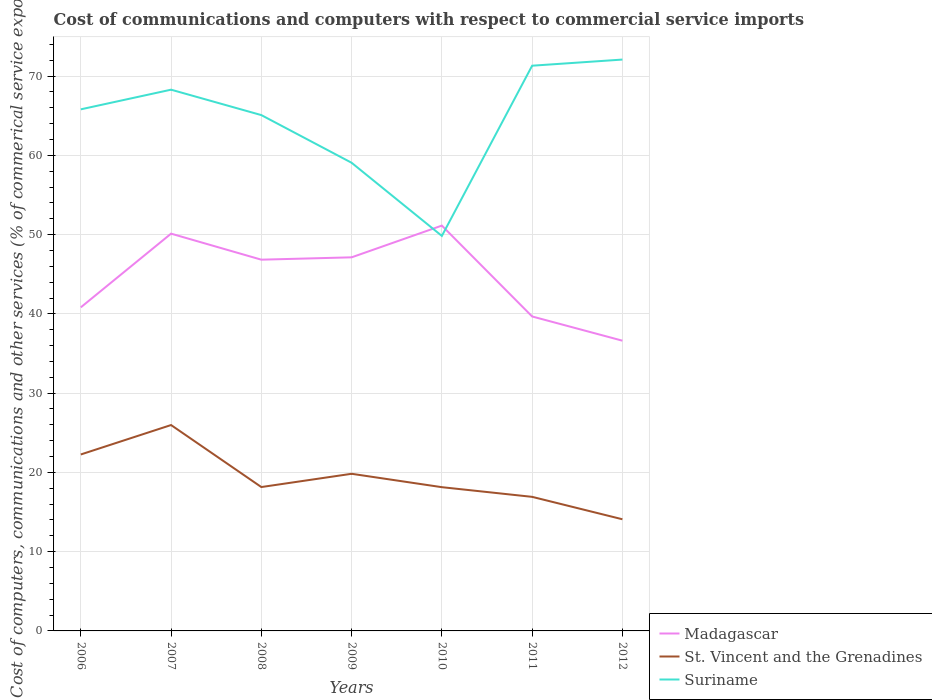Does the line corresponding to St. Vincent and the Grenadines intersect with the line corresponding to Suriname?
Provide a succinct answer. No. Across all years, what is the maximum cost of communications and computers in Suriname?
Your answer should be compact. 49.83. What is the total cost of communications and computers in Suriname in the graph?
Provide a short and direct response. -3.8. What is the difference between the highest and the second highest cost of communications and computers in St. Vincent and the Grenadines?
Your response must be concise. 11.89. How many lines are there?
Your answer should be compact. 3. Are the values on the major ticks of Y-axis written in scientific E-notation?
Make the answer very short. No. Does the graph contain any zero values?
Offer a terse response. No. Does the graph contain grids?
Offer a terse response. Yes. How many legend labels are there?
Ensure brevity in your answer.  3. What is the title of the graph?
Your answer should be compact. Cost of communications and computers with respect to commercial service imports. What is the label or title of the X-axis?
Provide a short and direct response. Years. What is the label or title of the Y-axis?
Give a very brief answer. Cost of computers, communications and other services (% of commerical service exports). What is the Cost of computers, communications and other services (% of commerical service exports) in Madagascar in 2006?
Offer a terse response. 40.82. What is the Cost of computers, communications and other services (% of commerical service exports) in St. Vincent and the Grenadines in 2006?
Make the answer very short. 22.26. What is the Cost of computers, communications and other services (% of commerical service exports) of Suriname in 2006?
Your response must be concise. 65.8. What is the Cost of computers, communications and other services (% of commerical service exports) in Madagascar in 2007?
Your answer should be very brief. 50.12. What is the Cost of computers, communications and other services (% of commerical service exports) of St. Vincent and the Grenadines in 2007?
Provide a short and direct response. 25.97. What is the Cost of computers, communications and other services (% of commerical service exports) in Suriname in 2007?
Offer a terse response. 68.28. What is the Cost of computers, communications and other services (% of commerical service exports) in Madagascar in 2008?
Make the answer very short. 46.84. What is the Cost of computers, communications and other services (% of commerical service exports) in St. Vincent and the Grenadines in 2008?
Make the answer very short. 18.15. What is the Cost of computers, communications and other services (% of commerical service exports) of Suriname in 2008?
Offer a very short reply. 65.08. What is the Cost of computers, communications and other services (% of commerical service exports) of Madagascar in 2009?
Keep it short and to the point. 47.13. What is the Cost of computers, communications and other services (% of commerical service exports) of St. Vincent and the Grenadines in 2009?
Offer a very short reply. 19.82. What is the Cost of computers, communications and other services (% of commerical service exports) in Suriname in 2009?
Your answer should be compact. 59.06. What is the Cost of computers, communications and other services (% of commerical service exports) of Madagascar in 2010?
Provide a succinct answer. 51.13. What is the Cost of computers, communications and other services (% of commerical service exports) of St. Vincent and the Grenadines in 2010?
Give a very brief answer. 18.13. What is the Cost of computers, communications and other services (% of commerical service exports) of Suriname in 2010?
Your answer should be very brief. 49.83. What is the Cost of computers, communications and other services (% of commerical service exports) of Madagascar in 2011?
Your response must be concise. 39.67. What is the Cost of computers, communications and other services (% of commerical service exports) in St. Vincent and the Grenadines in 2011?
Offer a terse response. 16.91. What is the Cost of computers, communications and other services (% of commerical service exports) in Suriname in 2011?
Offer a very short reply. 71.31. What is the Cost of computers, communications and other services (% of commerical service exports) of Madagascar in 2012?
Your answer should be compact. 36.62. What is the Cost of computers, communications and other services (% of commerical service exports) in St. Vincent and the Grenadines in 2012?
Your answer should be compact. 14.09. What is the Cost of computers, communications and other services (% of commerical service exports) in Suriname in 2012?
Ensure brevity in your answer.  72.08. Across all years, what is the maximum Cost of computers, communications and other services (% of commerical service exports) of Madagascar?
Your answer should be compact. 51.13. Across all years, what is the maximum Cost of computers, communications and other services (% of commerical service exports) in St. Vincent and the Grenadines?
Keep it short and to the point. 25.97. Across all years, what is the maximum Cost of computers, communications and other services (% of commerical service exports) in Suriname?
Keep it short and to the point. 72.08. Across all years, what is the minimum Cost of computers, communications and other services (% of commerical service exports) of Madagascar?
Keep it short and to the point. 36.62. Across all years, what is the minimum Cost of computers, communications and other services (% of commerical service exports) in St. Vincent and the Grenadines?
Keep it short and to the point. 14.09. Across all years, what is the minimum Cost of computers, communications and other services (% of commerical service exports) in Suriname?
Keep it short and to the point. 49.83. What is the total Cost of computers, communications and other services (% of commerical service exports) of Madagascar in the graph?
Your answer should be very brief. 312.33. What is the total Cost of computers, communications and other services (% of commerical service exports) of St. Vincent and the Grenadines in the graph?
Provide a succinct answer. 135.34. What is the total Cost of computers, communications and other services (% of commerical service exports) in Suriname in the graph?
Make the answer very short. 451.45. What is the difference between the Cost of computers, communications and other services (% of commerical service exports) of Madagascar in 2006 and that in 2007?
Make the answer very short. -9.3. What is the difference between the Cost of computers, communications and other services (% of commerical service exports) of St. Vincent and the Grenadines in 2006 and that in 2007?
Your answer should be compact. -3.71. What is the difference between the Cost of computers, communications and other services (% of commerical service exports) in Suriname in 2006 and that in 2007?
Provide a succinct answer. -2.48. What is the difference between the Cost of computers, communications and other services (% of commerical service exports) in Madagascar in 2006 and that in 2008?
Keep it short and to the point. -6.02. What is the difference between the Cost of computers, communications and other services (% of commerical service exports) in St. Vincent and the Grenadines in 2006 and that in 2008?
Provide a succinct answer. 4.11. What is the difference between the Cost of computers, communications and other services (% of commerical service exports) of Suriname in 2006 and that in 2008?
Your response must be concise. 0.73. What is the difference between the Cost of computers, communications and other services (% of commerical service exports) in Madagascar in 2006 and that in 2009?
Offer a terse response. -6.31. What is the difference between the Cost of computers, communications and other services (% of commerical service exports) in St. Vincent and the Grenadines in 2006 and that in 2009?
Provide a succinct answer. 2.44. What is the difference between the Cost of computers, communications and other services (% of commerical service exports) of Suriname in 2006 and that in 2009?
Give a very brief answer. 6.74. What is the difference between the Cost of computers, communications and other services (% of commerical service exports) of Madagascar in 2006 and that in 2010?
Your answer should be very brief. -10.31. What is the difference between the Cost of computers, communications and other services (% of commerical service exports) in St. Vincent and the Grenadines in 2006 and that in 2010?
Offer a terse response. 4.13. What is the difference between the Cost of computers, communications and other services (% of commerical service exports) of Suriname in 2006 and that in 2010?
Ensure brevity in your answer.  15.97. What is the difference between the Cost of computers, communications and other services (% of commerical service exports) in Madagascar in 2006 and that in 2011?
Offer a very short reply. 1.15. What is the difference between the Cost of computers, communications and other services (% of commerical service exports) in St. Vincent and the Grenadines in 2006 and that in 2011?
Make the answer very short. 5.35. What is the difference between the Cost of computers, communications and other services (% of commerical service exports) of Suriname in 2006 and that in 2011?
Your answer should be very brief. -5.5. What is the difference between the Cost of computers, communications and other services (% of commerical service exports) in Madagascar in 2006 and that in 2012?
Keep it short and to the point. 4.21. What is the difference between the Cost of computers, communications and other services (% of commerical service exports) of St. Vincent and the Grenadines in 2006 and that in 2012?
Provide a succinct answer. 8.17. What is the difference between the Cost of computers, communications and other services (% of commerical service exports) of Suriname in 2006 and that in 2012?
Keep it short and to the point. -6.28. What is the difference between the Cost of computers, communications and other services (% of commerical service exports) in Madagascar in 2007 and that in 2008?
Your answer should be compact. 3.28. What is the difference between the Cost of computers, communications and other services (% of commerical service exports) of St. Vincent and the Grenadines in 2007 and that in 2008?
Offer a very short reply. 7.82. What is the difference between the Cost of computers, communications and other services (% of commerical service exports) of Suriname in 2007 and that in 2008?
Give a very brief answer. 3.21. What is the difference between the Cost of computers, communications and other services (% of commerical service exports) of Madagascar in 2007 and that in 2009?
Your response must be concise. 2.99. What is the difference between the Cost of computers, communications and other services (% of commerical service exports) of St. Vincent and the Grenadines in 2007 and that in 2009?
Give a very brief answer. 6.15. What is the difference between the Cost of computers, communications and other services (% of commerical service exports) of Suriname in 2007 and that in 2009?
Ensure brevity in your answer.  9.22. What is the difference between the Cost of computers, communications and other services (% of commerical service exports) in Madagascar in 2007 and that in 2010?
Provide a short and direct response. -1.02. What is the difference between the Cost of computers, communications and other services (% of commerical service exports) in St. Vincent and the Grenadines in 2007 and that in 2010?
Provide a short and direct response. 7.84. What is the difference between the Cost of computers, communications and other services (% of commerical service exports) of Suriname in 2007 and that in 2010?
Your answer should be compact. 18.45. What is the difference between the Cost of computers, communications and other services (% of commerical service exports) in Madagascar in 2007 and that in 2011?
Your answer should be very brief. 10.45. What is the difference between the Cost of computers, communications and other services (% of commerical service exports) in St. Vincent and the Grenadines in 2007 and that in 2011?
Make the answer very short. 9.06. What is the difference between the Cost of computers, communications and other services (% of commerical service exports) in Suriname in 2007 and that in 2011?
Your answer should be compact. -3.02. What is the difference between the Cost of computers, communications and other services (% of commerical service exports) in Madagascar in 2007 and that in 2012?
Keep it short and to the point. 13.5. What is the difference between the Cost of computers, communications and other services (% of commerical service exports) in St. Vincent and the Grenadines in 2007 and that in 2012?
Your answer should be very brief. 11.89. What is the difference between the Cost of computers, communications and other services (% of commerical service exports) of Suriname in 2007 and that in 2012?
Give a very brief answer. -3.8. What is the difference between the Cost of computers, communications and other services (% of commerical service exports) of Madagascar in 2008 and that in 2009?
Your answer should be compact. -0.3. What is the difference between the Cost of computers, communications and other services (% of commerical service exports) of St. Vincent and the Grenadines in 2008 and that in 2009?
Ensure brevity in your answer.  -1.67. What is the difference between the Cost of computers, communications and other services (% of commerical service exports) in Suriname in 2008 and that in 2009?
Provide a succinct answer. 6.01. What is the difference between the Cost of computers, communications and other services (% of commerical service exports) in Madagascar in 2008 and that in 2010?
Keep it short and to the point. -4.3. What is the difference between the Cost of computers, communications and other services (% of commerical service exports) of St. Vincent and the Grenadines in 2008 and that in 2010?
Your answer should be compact. 0.02. What is the difference between the Cost of computers, communications and other services (% of commerical service exports) in Suriname in 2008 and that in 2010?
Give a very brief answer. 15.24. What is the difference between the Cost of computers, communications and other services (% of commerical service exports) of Madagascar in 2008 and that in 2011?
Your answer should be very brief. 7.16. What is the difference between the Cost of computers, communications and other services (% of commerical service exports) of St. Vincent and the Grenadines in 2008 and that in 2011?
Ensure brevity in your answer.  1.24. What is the difference between the Cost of computers, communications and other services (% of commerical service exports) of Suriname in 2008 and that in 2011?
Ensure brevity in your answer.  -6.23. What is the difference between the Cost of computers, communications and other services (% of commerical service exports) of Madagascar in 2008 and that in 2012?
Provide a succinct answer. 10.22. What is the difference between the Cost of computers, communications and other services (% of commerical service exports) of St. Vincent and the Grenadines in 2008 and that in 2012?
Your response must be concise. 4.07. What is the difference between the Cost of computers, communications and other services (% of commerical service exports) of Suriname in 2008 and that in 2012?
Provide a succinct answer. -7.01. What is the difference between the Cost of computers, communications and other services (% of commerical service exports) in Madagascar in 2009 and that in 2010?
Provide a succinct answer. -4. What is the difference between the Cost of computers, communications and other services (% of commerical service exports) in St. Vincent and the Grenadines in 2009 and that in 2010?
Your response must be concise. 1.69. What is the difference between the Cost of computers, communications and other services (% of commerical service exports) in Suriname in 2009 and that in 2010?
Your answer should be compact. 9.23. What is the difference between the Cost of computers, communications and other services (% of commerical service exports) of Madagascar in 2009 and that in 2011?
Your response must be concise. 7.46. What is the difference between the Cost of computers, communications and other services (% of commerical service exports) of St. Vincent and the Grenadines in 2009 and that in 2011?
Keep it short and to the point. 2.91. What is the difference between the Cost of computers, communications and other services (% of commerical service exports) in Suriname in 2009 and that in 2011?
Make the answer very short. -12.24. What is the difference between the Cost of computers, communications and other services (% of commerical service exports) of Madagascar in 2009 and that in 2012?
Give a very brief answer. 10.52. What is the difference between the Cost of computers, communications and other services (% of commerical service exports) of St. Vincent and the Grenadines in 2009 and that in 2012?
Your answer should be very brief. 5.74. What is the difference between the Cost of computers, communications and other services (% of commerical service exports) in Suriname in 2009 and that in 2012?
Offer a terse response. -13.02. What is the difference between the Cost of computers, communications and other services (% of commerical service exports) of Madagascar in 2010 and that in 2011?
Ensure brevity in your answer.  11.46. What is the difference between the Cost of computers, communications and other services (% of commerical service exports) in St. Vincent and the Grenadines in 2010 and that in 2011?
Your answer should be compact. 1.22. What is the difference between the Cost of computers, communications and other services (% of commerical service exports) in Suriname in 2010 and that in 2011?
Provide a short and direct response. -21.48. What is the difference between the Cost of computers, communications and other services (% of commerical service exports) of Madagascar in 2010 and that in 2012?
Provide a short and direct response. 14.52. What is the difference between the Cost of computers, communications and other services (% of commerical service exports) of St. Vincent and the Grenadines in 2010 and that in 2012?
Your answer should be very brief. 4.05. What is the difference between the Cost of computers, communications and other services (% of commerical service exports) in Suriname in 2010 and that in 2012?
Offer a very short reply. -22.25. What is the difference between the Cost of computers, communications and other services (% of commerical service exports) of Madagascar in 2011 and that in 2012?
Offer a very short reply. 3.06. What is the difference between the Cost of computers, communications and other services (% of commerical service exports) in St. Vincent and the Grenadines in 2011 and that in 2012?
Provide a short and direct response. 2.83. What is the difference between the Cost of computers, communications and other services (% of commerical service exports) of Suriname in 2011 and that in 2012?
Your answer should be very brief. -0.78. What is the difference between the Cost of computers, communications and other services (% of commerical service exports) in Madagascar in 2006 and the Cost of computers, communications and other services (% of commerical service exports) in St. Vincent and the Grenadines in 2007?
Your answer should be very brief. 14.85. What is the difference between the Cost of computers, communications and other services (% of commerical service exports) in Madagascar in 2006 and the Cost of computers, communications and other services (% of commerical service exports) in Suriname in 2007?
Provide a short and direct response. -27.46. What is the difference between the Cost of computers, communications and other services (% of commerical service exports) in St. Vincent and the Grenadines in 2006 and the Cost of computers, communications and other services (% of commerical service exports) in Suriname in 2007?
Give a very brief answer. -46.02. What is the difference between the Cost of computers, communications and other services (% of commerical service exports) of Madagascar in 2006 and the Cost of computers, communications and other services (% of commerical service exports) of St. Vincent and the Grenadines in 2008?
Ensure brevity in your answer.  22.67. What is the difference between the Cost of computers, communications and other services (% of commerical service exports) of Madagascar in 2006 and the Cost of computers, communications and other services (% of commerical service exports) of Suriname in 2008?
Give a very brief answer. -24.26. What is the difference between the Cost of computers, communications and other services (% of commerical service exports) in St. Vincent and the Grenadines in 2006 and the Cost of computers, communications and other services (% of commerical service exports) in Suriname in 2008?
Ensure brevity in your answer.  -42.82. What is the difference between the Cost of computers, communications and other services (% of commerical service exports) of Madagascar in 2006 and the Cost of computers, communications and other services (% of commerical service exports) of St. Vincent and the Grenadines in 2009?
Offer a very short reply. 21. What is the difference between the Cost of computers, communications and other services (% of commerical service exports) of Madagascar in 2006 and the Cost of computers, communications and other services (% of commerical service exports) of Suriname in 2009?
Offer a terse response. -18.24. What is the difference between the Cost of computers, communications and other services (% of commerical service exports) of St. Vincent and the Grenadines in 2006 and the Cost of computers, communications and other services (% of commerical service exports) of Suriname in 2009?
Provide a short and direct response. -36.8. What is the difference between the Cost of computers, communications and other services (% of commerical service exports) of Madagascar in 2006 and the Cost of computers, communications and other services (% of commerical service exports) of St. Vincent and the Grenadines in 2010?
Keep it short and to the point. 22.69. What is the difference between the Cost of computers, communications and other services (% of commerical service exports) in Madagascar in 2006 and the Cost of computers, communications and other services (% of commerical service exports) in Suriname in 2010?
Offer a very short reply. -9.01. What is the difference between the Cost of computers, communications and other services (% of commerical service exports) of St. Vincent and the Grenadines in 2006 and the Cost of computers, communications and other services (% of commerical service exports) of Suriname in 2010?
Keep it short and to the point. -27.57. What is the difference between the Cost of computers, communications and other services (% of commerical service exports) in Madagascar in 2006 and the Cost of computers, communications and other services (% of commerical service exports) in St. Vincent and the Grenadines in 2011?
Ensure brevity in your answer.  23.91. What is the difference between the Cost of computers, communications and other services (% of commerical service exports) in Madagascar in 2006 and the Cost of computers, communications and other services (% of commerical service exports) in Suriname in 2011?
Provide a short and direct response. -30.49. What is the difference between the Cost of computers, communications and other services (% of commerical service exports) of St. Vincent and the Grenadines in 2006 and the Cost of computers, communications and other services (% of commerical service exports) of Suriname in 2011?
Your response must be concise. -49.05. What is the difference between the Cost of computers, communications and other services (% of commerical service exports) in Madagascar in 2006 and the Cost of computers, communications and other services (% of commerical service exports) in St. Vincent and the Grenadines in 2012?
Offer a very short reply. 26.73. What is the difference between the Cost of computers, communications and other services (% of commerical service exports) in Madagascar in 2006 and the Cost of computers, communications and other services (% of commerical service exports) in Suriname in 2012?
Provide a succinct answer. -31.26. What is the difference between the Cost of computers, communications and other services (% of commerical service exports) in St. Vincent and the Grenadines in 2006 and the Cost of computers, communications and other services (% of commerical service exports) in Suriname in 2012?
Ensure brevity in your answer.  -49.82. What is the difference between the Cost of computers, communications and other services (% of commerical service exports) in Madagascar in 2007 and the Cost of computers, communications and other services (% of commerical service exports) in St. Vincent and the Grenadines in 2008?
Provide a succinct answer. 31.97. What is the difference between the Cost of computers, communications and other services (% of commerical service exports) of Madagascar in 2007 and the Cost of computers, communications and other services (% of commerical service exports) of Suriname in 2008?
Make the answer very short. -14.96. What is the difference between the Cost of computers, communications and other services (% of commerical service exports) in St. Vincent and the Grenadines in 2007 and the Cost of computers, communications and other services (% of commerical service exports) in Suriname in 2008?
Keep it short and to the point. -39.1. What is the difference between the Cost of computers, communications and other services (% of commerical service exports) of Madagascar in 2007 and the Cost of computers, communications and other services (% of commerical service exports) of St. Vincent and the Grenadines in 2009?
Offer a very short reply. 30.3. What is the difference between the Cost of computers, communications and other services (% of commerical service exports) of Madagascar in 2007 and the Cost of computers, communications and other services (% of commerical service exports) of Suriname in 2009?
Ensure brevity in your answer.  -8.94. What is the difference between the Cost of computers, communications and other services (% of commerical service exports) in St. Vincent and the Grenadines in 2007 and the Cost of computers, communications and other services (% of commerical service exports) in Suriname in 2009?
Your answer should be very brief. -33.09. What is the difference between the Cost of computers, communications and other services (% of commerical service exports) of Madagascar in 2007 and the Cost of computers, communications and other services (% of commerical service exports) of St. Vincent and the Grenadines in 2010?
Your response must be concise. 31.98. What is the difference between the Cost of computers, communications and other services (% of commerical service exports) of Madagascar in 2007 and the Cost of computers, communications and other services (% of commerical service exports) of Suriname in 2010?
Your answer should be compact. 0.29. What is the difference between the Cost of computers, communications and other services (% of commerical service exports) in St. Vincent and the Grenadines in 2007 and the Cost of computers, communications and other services (% of commerical service exports) in Suriname in 2010?
Make the answer very short. -23.86. What is the difference between the Cost of computers, communications and other services (% of commerical service exports) in Madagascar in 2007 and the Cost of computers, communications and other services (% of commerical service exports) in St. Vincent and the Grenadines in 2011?
Your answer should be compact. 33.2. What is the difference between the Cost of computers, communications and other services (% of commerical service exports) of Madagascar in 2007 and the Cost of computers, communications and other services (% of commerical service exports) of Suriname in 2011?
Keep it short and to the point. -21.19. What is the difference between the Cost of computers, communications and other services (% of commerical service exports) in St. Vincent and the Grenadines in 2007 and the Cost of computers, communications and other services (% of commerical service exports) in Suriname in 2011?
Ensure brevity in your answer.  -45.33. What is the difference between the Cost of computers, communications and other services (% of commerical service exports) in Madagascar in 2007 and the Cost of computers, communications and other services (% of commerical service exports) in St. Vincent and the Grenadines in 2012?
Your response must be concise. 36.03. What is the difference between the Cost of computers, communications and other services (% of commerical service exports) in Madagascar in 2007 and the Cost of computers, communications and other services (% of commerical service exports) in Suriname in 2012?
Offer a terse response. -21.96. What is the difference between the Cost of computers, communications and other services (% of commerical service exports) in St. Vincent and the Grenadines in 2007 and the Cost of computers, communications and other services (% of commerical service exports) in Suriname in 2012?
Give a very brief answer. -46.11. What is the difference between the Cost of computers, communications and other services (% of commerical service exports) of Madagascar in 2008 and the Cost of computers, communications and other services (% of commerical service exports) of St. Vincent and the Grenadines in 2009?
Provide a succinct answer. 27.01. What is the difference between the Cost of computers, communications and other services (% of commerical service exports) of Madagascar in 2008 and the Cost of computers, communications and other services (% of commerical service exports) of Suriname in 2009?
Your response must be concise. -12.23. What is the difference between the Cost of computers, communications and other services (% of commerical service exports) of St. Vincent and the Grenadines in 2008 and the Cost of computers, communications and other services (% of commerical service exports) of Suriname in 2009?
Ensure brevity in your answer.  -40.91. What is the difference between the Cost of computers, communications and other services (% of commerical service exports) of Madagascar in 2008 and the Cost of computers, communications and other services (% of commerical service exports) of St. Vincent and the Grenadines in 2010?
Give a very brief answer. 28.7. What is the difference between the Cost of computers, communications and other services (% of commerical service exports) in Madagascar in 2008 and the Cost of computers, communications and other services (% of commerical service exports) in Suriname in 2010?
Your response must be concise. -3. What is the difference between the Cost of computers, communications and other services (% of commerical service exports) of St. Vincent and the Grenadines in 2008 and the Cost of computers, communications and other services (% of commerical service exports) of Suriname in 2010?
Give a very brief answer. -31.68. What is the difference between the Cost of computers, communications and other services (% of commerical service exports) in Madagascar in 2008 and the Cost of computers, communications and other services (% of commerical service exports) in St. Vincent and the Grenadines in 2011?
Your answer should be compact. 29.92. What is the difference between the Cost of computers, communications and other services (% of commerical service exports) of Madagascar in 2008 and the Cost of computers, communications and other services (% of commerical service exports) of Suriname in 2011?
Your answer should be compact. -24.47. What is the difference between the Cost of computers, communications and other services (% of commerical service exports) of St. Vincent and the Grenadines in 2008 and the Cost of computers, communications and other services (% of commerical service exports) of Suriname in 2011?
Provide a succinct answer. -53.16. What is the difference between the Cost of computers, communications and other services (% of commerical service exports) in Madagascar in 2008 and the Cost of computers, communications and other services (% of commerical service exports) in St. Vincent and the Grenadines in 2012?
Keep it short and to the point. 32.75. What is the difference between the Cost of computers, communications and other services (% of commerical service exports) of Madagascar in 2008 and the Cost of computers, communications and other services (% of commerical service exports) of Suriname in 2012?
Your response must be concise. -25.25. What is the difference between the Cost of computers, communications and other services (% of commerical service exports) of St. Vincent and the Grenadines in 2008 and the Cost of computers, communications and other services (% of commerical service exports) of Suriname in 2012?
Ensure brevity in your answer.  -53.93. What is the difference between the Cost of computers, communications and other services (% of commerical service exports) of Madagascar in 2009 and the Cost of computers, communications and other services (% of commerical service exports) of St. Vincent and the Grenadines in 2010?
Your answer should be compact. 29. What is the difference between the Cost of computers, communications and other services (% of commerical service exports) in St. Vincent and the Grenadines in 2009 and the Cost of computers, communications and other services (% of commerical service exports) in Suriname in 2010?
Your response must be concise. -30.01. What is the difference between the Cost of computers, communications and other services (% of commerical service exports) of Madagascar in 2009 and the Cost of computers, communications and other services (% of commerical service exports) of St. Vincent and the Grenadines in 2011?
Your answer should be compact. 30.22. What is the difference between the Cost of computers, communications and other services (% of commerical service exports) in Madagascar in 2009 and the Cost of computers, communications and other services (% of commerical service exports) in Suriname in 2011?
Your response must be concise. -24.18. What is the difference between the Cost of computers, communications and other services (% of commerical service exports) of St. Vincent and the Grenadines in 2009 and the Cost of computers, communications and other services (% of commerical service exports) of Suriname in 2011?
Provide a succinct answer. -51.48. What is the difference between the Cost of computers, communications and other services (% of commerical service exports) of Madagascar in 2009 and the Cost of computers, communications and other services (% of commerical service exports) of St. Vincent and the Grenadines in 2012?
Make the answer very short. 33.05. What is the difference between the Cost of computers, communications and other services (% of commerical service exports) of Madagascar in 2009 and the Cost of computers, communications and other services (% of commerical service exports) of Suriname in 2012?
Offer a very short reply. -24.95. What is the difference between the Cost of computers, communications and other services (% of commerical service exports) of St. Vincent and the Grenadines in 2009 and the Cost of computers, communications and other services (% of commerical service exports) of Suriname in 2012?
Your response must be concise. -52.26. What is the difference between the Cost of computers, communications and other services (% of commerical service exports) in Madagascar in 2010 and the Cost of computers, communications and other services (% of commerical service exports) in St. Vincent and the Grenadines in 2011?
Offer a terse response. 34.22. What is the difference between the Cost of computers, communications and other services (% of commerical service exports) in Madagascar in 2010 and the Cost of computers, communications and other services (% of commerical service exports) in Suriname in 2011?
Your answer should be compact. -20.17. What is the difference between the Cost of computers, communications and other services (% of commerical service exports) of St. Vincent and the Grenadines in 2010 and the Cost of computers, communications and other services (% of commerical service exports) of Suriname in 2011?
Offer a terse response. -53.17. What is the difference between the Cost of computers, communications and other services (% of commerical service exports) of Madagascar in 2010 and the Cost of computers, communications and other services (% of commerical service exports) of St. Vincent and the Grenadines in 2012?
Offer a very short reply. 37.05. What is the difference between the Cost of computers, communications and other services (% of commerical service exports) in Madagascar in 2010 and the Cost of computers, communications and other services (% of commerical service exports) in Suriname in 2012?
Offer a terse response. -20.95. What is the difference between the Cost of computers, communications and other services (% of commerical service exports) of St. Vincent and the Grenadines in 2010 and the Cost of computers, communications and other services (% of commerical service exports) of Suriname in 2012?
Provide a short and direct response. -53.95. What is the difference between the Cost of computers, communications and other services (% of commerical service exports) in Madagascar in 2011 and the Cost of computers, communications and other services (% of commerical service exports) in St. Vincent and the Grenadines in 2012?
Your answer should be very brief. 25.59. What is the difference between the Cost of computers, communications and other services (% of commerical service exports) of Madagascar in 2011 and the Cost of computers, communications and other services (% of commerical service exports) of Suriname in 2012?
Provide a short and direct response. -32.41. What is the difference between the Cost of computers, communications and other services (% of commerical service exports) in St. Vincent and the Grenadines in 2011 and the Cost of computers, communications and other services (% of commerical service exports) in Suriname in 2012?
Your answer should be compact. -55.17. What is the average Cost of computers, communications and other services (% of commerical service exports) of Madagascar per year?
Make the answer very short. 44.62. What is the average Cost of computers, communications and other services (% of commerical service exports) of St. Vincent and the Grenadines per year?
Offer a terse response. 19.33. What is the average Cost of computers, communications and other services (% of commerical service exports) in Suriname per year?
Your answer should be compact. 64.49. In the year 2006, what is the difference between the Cost of computers, communications and other services (% of commerical service exports) of Madagascar and Cost of computers, communications and other services (% of commerical service exports) of St. Vincent and the Grenadines?
Offer a very short reply. 18.56. In the year 2006, what is the difference between the Cost of computers, communications and other services (% of commerical service exports) of Madagascar and Cost of computers, communications and other services (% of commerical service exports) of Suriname?
Ensure brevity in your answer.  -24.98. In the year 2006, what is the difference between the Cost of computers, communications and other services (% of commerical service exports) in St. Vincent and the Grenadines and Cost of computers, communications and other services (% of commerical service exports) in Suriname?
Offer a very short reply. -43.54. In the year 2007, what is the difference between the Cost of computers, communications and other services (% of commerical service exports) in Madagascar and Cost of computers, communications and other services (% of commerical service exports) in St. Vincent and the Grenadines?
Your response must be concise. 24.14. In the year 2007, what is the difference between the Cost of computers, communications and other services (% of commerical service exports) of Madagascar and Cost of computers, communications and other services (% of commerical service exports) of Suriname?
Your response must be concise. -18.16. In the year 2007, what is the difference between the Cost of computers, communications and other services (% of commerical service exports) in St. Vincent and the Grenadines and Cost of computers, communications and other services (% of commerical service exports) in Suriname?
Your answer should be compact. -42.31. In the year 2008, what is the difference between the Cost of computers, communications and other services (% of commerical service exports) in Madagascar and Cost of computers, communications and other services (% of commerical service exports) in St. Vincent and the Grenadines?
Offer a terse response. 28.68. In the year 2008, what is the difference between the Cost of computers, communications and other services (% of commerical service exports) of Madagascar and Cost of computers, communications and other services (% of commerical service exports) of Suriname?
Your answer should be compact. -18.24. In the year 2008, what is the difference between the Cost of computers, communications and other services (% of commerical service exports) of St. Vincent and the Grenadines and Cost of computers, communications and other services (% of commerical service exports) of Suriname?
Ensure brevity in your answer.  -46.93. In the year 2009, what is the difference between the Cost of computers, communications and other services (% of commerical service exports) of Madagascar and Cost of computers, communications and other services (% of commerical service exports) of St. Vincent and the Grenadines?
Offer a very short reply. 27.31. In the year 2009, what is the difference between the Cost of computers, communications and other services (% of commerical service exports) in Madagascar and Cost of computers, communications and other services (% of commerical service exports) in Suriname?
Ensure brevity in your answer.  -11.93. In the year 2009, what is the difference between the Cost of computers, communications and other services (% of commerical service exports) of St. Vincent and the Grenadines and Cost of computers, communications and other services (% of commerical service exports) of Suriname?
Ensure brevity in your answer.  -39.24. In the year 2010, what is the difference between the Cost of computers, communications and other services (% of commerical service exports) in Madagascar and Cost of computers, communications and other services (% of commerical service exports) in St. Vincent and the Grenadines?
Provide a short and direct response. 33. In the year 2010, what is the difference between the Cost of computers, communications and other services (% of commerical service exports) of Madagascar and Cost of computers, communications and other services (% of commerical service exports) of Suriname?
Ensure brevity in your answer.  1.3. In the year 2010, what is the difference between the Cost of computers, communications and other services (% of commerical service exports) of St. Vincent and the Grenadines and Cost of computers, communications and other services (% of commerical service exports) of Suriname?
Provide a short and direct response. -31.7. In the year 2011, what is the difference between the Cost of computers, communications and other services (% of commerical service exports) of Madagascar and Cost of computers, communications and other services (% of commerical service exports) of St. Vincent and the Grenadines?
Provide a short and direct response. 22.76. In the year 2011, what is the difference between the Cost of computers, communications and other services (% of commerical service exports) of Madagascar and Cost of computers, communications and other services (% of commerical service exports) of Suriname?
Your response must be concise. -31.64. In the year 2011, what is the difference between the Cost of computers, communications and other services (% of commerical service exports) of St. Vincent and the Grenadines and Cost of computers, communications and other services (% of commerical service exports) of Suriname?
Provide a succinct answer. -54.39. In the year 2012, what is the difference between the Cost of computers, communications and other services (% of commerical service exports) of Madagascar and Cost of computers, communications and other services (% of commerical service exports) of St. Vincent and the Grenadines?
Your answer should be compact. 22.53. In the year 2012, what is the difference between the Cost of computers, communications and other services (% of commerical service exports) in Madagascar and Cost of computers, communications and other services (% of commerical service exports) in Suriname?
Offer a terse response. -35.47. In the year 2012, what is the difference between the Cost of computers, communications and other services (% of commerical service exports) of St. Vincent and the Grenadines and Cost of computers, communications and other services (% of commerical service exports) of Suriname?
Offer a very short reply. -58. What is the ratio of the Cost of computers, communications and other services (% of commerical service exports) in Madagascar in 2006 to that in 2007?
Give a very brief answer. 0.81. What is the ratio of the Cost of computers, communications and other services (% of commerical service exports) in St. Vincent and the Grenadines in 2006 to that in 2007?
Offer a very short reply. 0.86. What is the ratio of the Cost of computers, communications and other services (% of commerical service exports) of Suriname in 2006 to that in 2007?
Make the answer very short. 0.96. What is the ratio of the Cost of computers, communications and other services (% of commerical service exports) in Madagascar in 2006 to that in 2008?
Your answer should be very brief. 0.87. What is the ratio of the Cost of computers, communications and other services (% of commerical service exports) of St. Vincent and the Grenadines in 2006 to that in 2008?
Your answer should be very brief. 1.23. What is the ratio of the Cost of computers, communications and other services (% of commerical service exports) of Suriname in 2006 to that in 2008?
Your response must be concise. 1.01. What is the ratio of the Cost of computers, communications and other services (% of commerical service exports) of Madagascar in 2006 to that in 2009?
Your response must be concise. 0.87. What is the ratio of the Cost of computers, communications and other services (% of commerical service exports) in St. Vincent and the Grenadines in 2006 to that in 2009?
Offer a very short reply. 1.12. What is the ratio of the Cost of computers, communications and other services (% of commerical service exports) of Suriname in 2006 to that in 2009?
Provide a short and direct response. 1.11. What is the ratio of the Cost of computers, communications and other services (% of commerical service exports) in Madagascar in 2006 to that in 2010?
Your response must be concise. 0.8. What is the ratio of the Cost of computers, communications and other services (% of commerical service exports) of St. Vincent and the Grenadines in 2006 to that in 2010?
Keep it short and to the point. 1.23. What is the ratio of the Cost of computers, communications and other services (% of commerical service exports) of Suriname in 2006 to that in 2010?
Offer a very short reply. 1.32. What is the ratio of the Cost of computers, communications and other services (% of commerical service exports) of St. Vincent and the Grenadines in 2006 to that in 2011?
Give a very brief answer. 1.32. What is the ratio of the Cost of computers, communications and other services (% of commerical service exports) of Suriname in 2006 to that in 2011?
Your answer should be very brief. 0.92. What is the ratio of the Cost of computers, communications and other services (% of commerical service exports) in Madagascar in 2006 to that in 2012?
Keep it short and to the point. 1.11. What is the ratio of the Cost of computers, communications and other services (% of commerical service exports) of St. Vincent and the Grenadines in 2006 to that in 2012?
Offer a very short reply. 1.58. What is the ratio of the Cost of computers, communications and other services (% of commerical service exports) in Suriname in 2006 to that in 2012?
Provide a short and direct response. 0.91. What is the ratio of the Cost of computers, communications and other services (% of commerical service exports) in Madagascar in 2007 to that in 2008?
Ensure brevity in your answer.  1.07. What is the ratio of the Cost of computers, communications and other services (% of commerical service exports) in St. Vincent and the Grenadines in 2007 to that in 2008?
Your answer should be very brief. 1.43. What is the ratio of the Cost of computers, communications and other services (% of commerical service exports) in Suriname in 2007 to that in 2008?
Provide a short and direct response. 1.05. What is the ratio of the Cost of computers, communications and other services (% of commerical service exports) of Madagascar in 2007 to that in 2009?
Give a very brief answer. 1.06. What is the ratio of the Cost of computers, communications and other services (% of commerical service exports) of St. Vincent and the Grenadines in 2007 to that in 2009?
Ensure brevity in your answer.  1.31. What is the ratio of the Cost of computers, communications and other services (% of commerical service exports) of Suriname in 2007 to that in 2009?
Make the answer very short. 1.16. What is the ratio of the Cost of computers, communications and other services (% of commerical service exports) in Madagascar in 2007 to that in 2010?
Ensure brevity in your answer.  0.98. What is the ratio of the Cost of computers, communications and other services (% of commerical service exports) in St. Vincent and the Grenadines in 2007 to that in 2010?
Your answer should be very brief. 1.43. What is the ratio of the Cost of computers, communications and other services (% of commerical service exports) in Suriname in 2007 to that in 2010?
Offer a terse response. 1.37. What is the ratio of the Cost of computers, communications and other services (% of commerical service exports) in Madagascar in 2007 to that in 2011?
Provide a succinct answer. 1.26. What is the ratio of the Cost of computers, communications and other services (% of commerical service exports) in St. Vincent and the Grenadines in 2007 to that in 2011?
Provide a short and direct response. 1.54. What is the ratio of the Cost of computers, communications and other services (% of commerical service exports) of Suriname in 2007 to that in 2011?
Provide a succinct answer. 0.96. What is the ratio of the Cost of computers, communications and other services (% of commerical service exports) in Madagascar in 2007 to that in 2012?
Offer a very short reply. 1.37. What is the ratio of the Cost of computers, communications and other services (% of commerical service exports) of St. Vincent and the Grenadines in 2007 to that in 2012?
Keep it short and to the point. 1.84. What is the ratio of the Cost of computers, communications and other services (% of commerical service exports) in Suriname in 2007 to that in 2012?
Offer a terse response. 0.95. What is the ratio of the Cost of computers, communications and other services (% of commerical service exports) of St. Vincent and the Grenadines in 2008 to that in 2009?
Offer a terse response. 0.92. What is the ratio of the Cost of computers, communications and other services (% of commerical service exports) of Suriname in 2008 to that in 2009?
Provide a short and direct response. 1.1. What is the ratio of the Cost of computers, communications and other services (% of commerical service exports) of Madagascar in 2008 to that in 2010?
Keep it short and to the point. 0.92. What is the ratio of the Cost of computers, communications and other services (% of commerical service exports) in St. Vincent and the Grenadines in 2008 to that in 2010?
Keep it short and to the point. 1. What is the ratio of the Cost of computers, communications and other services (% of commerical service exports) in Suriname in 2008 to that in 2010?
Your response must be concise. 1.31. What is the ratio of the Cost of computers, communications and other services (% of commerical service exports) in Madagascar in 2008 to that in 2011?
Your response must be concise. 1.18. What is the ratio of the Cost of computers, communications and other services (% of commerical service exports) of St. Vincent and the Grenadines in 2008 to that in 2011?
Give a very brief answer. 1.07. What is the ratio of the Cost of computers, communications and other services (% of commerical service exports) of Suriname in 2008 to that in 2011?
Your answer should be compact. 0.91. What is the ratio of the Cost of computers, communications and other services (% of commerical service exports) of Madagascar in 2008 to that in 2012?
Your answer should be very brief. 1.28. What is the ratio of the Cost of computers, communications and other services (% of commerical service exports) of St. Vincent and the Grenadines in 2008 to that in 2012?
Make the answer very short. 1.29. What is the ratio of the Cost of computers, communications and other services (% of commerical service exports) of Suriname in 2008 to that in 2012?
Your answer should be compact. 0.9. What is the ratio of the Cost of computers, communications and other services (% of commerical service exports) in Madagascar in 2009 to that in 2010?
Provide a succinct answer. 0.92. What is the ratio of the Cost of computers, communications and other services (% of commerical service exports) in St. Vincent and the Grenadines in 2009 to that in 2010?
Your answer should be compact. 1.09. What is the ratio of the Cost of computers, communications and other services (% of commerical service exports) in Suriname in 2009 to that in 2010?
Provide a succinct answer. 1.19. What is the ratio of the Cost of computers, communications and other services (% of commerical service exports) in Madagascar in 2009 to that in 2011?
Provide a short and direct response. 1.19. What is the ratio of the Cost of computers, communications and other services (% of commerical service exports) in St. Vincent and the Grenadines in 2009 to that in 2011?
Your response must be concise. 1.17. What is the ratio of the Cost of computers, communications and other services (% of commerical service exports) of Suriname in 2009 to that in 2011?
Your response must be concise. 0.83. What is the ratio of the Cost of computers, communications and other services (% of commerical service exports) in Madagascar in 2009 to that in 2012?
Keep it short and to the point. 1.29. What is the ratio of the Cost of computers, communications and other services (% of commerical service exports) of St. Vincent and the Grenadines in 2009 to that in 2012?
Your answer should be compact. 1.41. What is the ratio of the Cost of computers, communications and other services (% of commerical service exports) of Suriname in 2009 to that in 2012?
Provide a succinct answer. 0.82. What is the ratio of the Cost of computers, communications and other services (% of commerical service exports) of Madagascar in 2010 to that in 2011?
Keep it short and to the point. 1.29. What is the ratio of the Cost of computers, communications and other services (% of commerical service exports) of St. Vincent and the Grenadines in 2010 to that in 2011?
Your answer should be very brief. 1.07. What is the ratio of the Cost of computers, communications and other services (% of commerical service exports) of Suriname in 2010 to that in 2011?
Your answer should be compact. 0.7. What is the ratio of the Cost of computers, communications and other services (% of commerical service exports) of Madagascar in 2010 to that in 2012?
Your response must be concise. 1.4. What is the ratio of the Cost of computers, communications and other services (% of commerical service exports) in St. Vincent and the Grenadines in 2010 to that in 2012?
Ensure brevity in your answer.  1.29. What is the ratio of the Cost of computers, communications and other services (% of commerical service exports) in Suriname in 2010 to that in 2012?
Provide a succinct answer. 0.69. What is the ratio of the Cost of computers, communications and other services (% of commerical service exports) of Madagascar in 2011 to that in 2012?
Make the answer very short. 1.08. What is the ratio of the Cost of computers, communications and other services (% of commerical service exports) in St. Vincent and the Grenadines in 2011 to that in 2012?
Keep it short and to the point. 1.2. What is the ratio of the Cost of computers, communications and other services (% of commerical service exports) in Suriname in 2011 to that in 2012?
Your answer should be compact. 0.99. What is the difference between the highest and the second highest Cost of computers, communications and other services (% of commerical service exports) in Madagascar?
Provide a succinct answer. 1.02. What is the difference between the highest and the second highest Cost of computers, communications and other services (% of commerical service exports) in St. Vincent and the Grenadines?
Give a very brief answer. 3.71. What is the difference between the highest and the second highest Cost of computers, communications and other services (% of commerical service exports) of Suriname?
Offer a terse response. 0.78. What is the difference between the highest and the lowest Cost of computers, communications and other services (% of commerical service exports) in Madagascar?
Offer a very short reply. 14.52. What is the difference between the highest and the lowest Cost of computers, communications and other services (% of commerical service exports) of St. Vincent and the Grenadines?
Provide a short and direct response. 11.89. What is the difference between the highest and the lowest Cost of computers, communications and other services (% of commerical service exports) in Suriname?
Your answer should be compact. 22.25. 